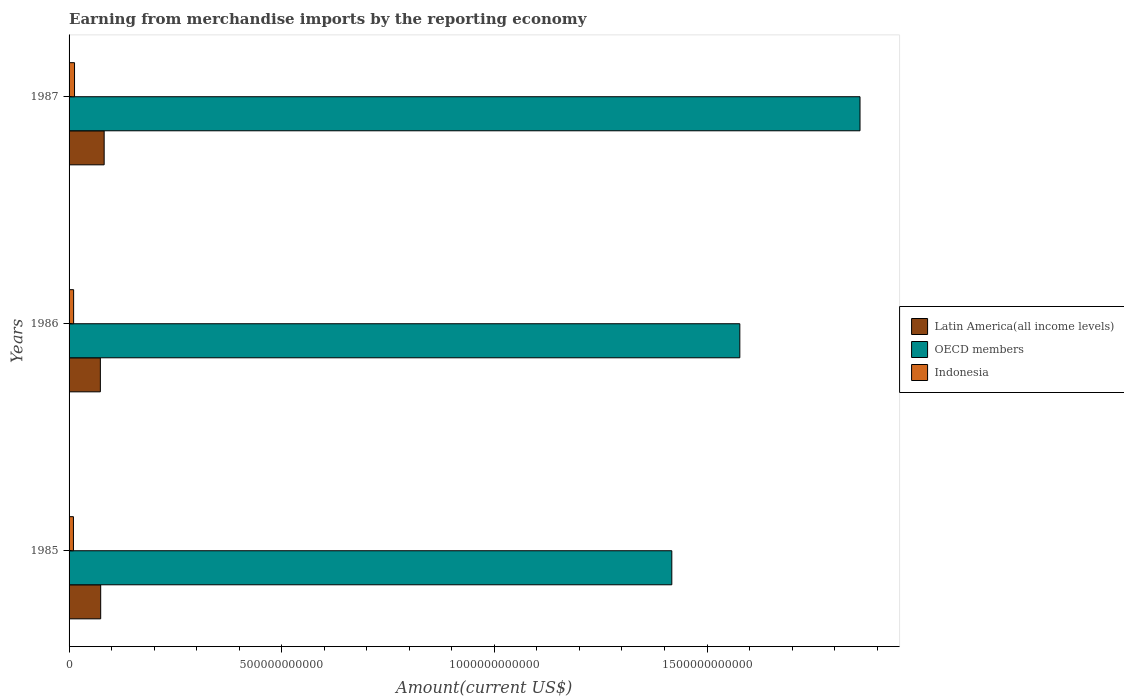How many different coloured bars are there?
Offer a very short reply. 3. Are the number of bars per tick equal to the number of legend labels?
Offer a very short reply. Yes. How many bars are there on the 1st tick from the top?
Give a very brief answer. 3. What is the label of the 3rd group of bars from the top?
Your answer should be compact. 1985. In how many cases, is the number of bars for a given year not equal to the number of legend labels?
Your answer should be very brief. 0. What is the amount earned from merchandise imports in OECD members in 1986?
Provide a short and direct response. 1.58e+12. Across all years, what is the maximum amount earned from merchandise imports in Latin America(all income levels)?
Ensure brevity in your answer.  8.25e+1. Across all years, what is the minimum amount earned from merchandise imports in Latin America(all income levels)?
Make the answer very short. 7.36e+1. In which year was the amount earned from merchandise imports in Indonesia maximum?
Make the answer very short. 1987. In which year was the amount earned from merchandise imports in Latin America(all income levels) minimum?
Provide a succinct answer. 1986. What is the total amount earned from merchandise imports in Indonesia in the graph?
Keep it short and to the point. 3.39e+1. What is the difference between the amount earned from merchandise imports in Indonesia in 1985 and that in 1986?
Your answer should be very brief. -4.50e+08. What is the difference between the amount earned from merchandise imports in Latin America(all income levels) in 1985 and the amount earned from merchandise imports in Indonesia in 1986?
Ensure brevity in your answer.  6.36e+1. What is the average amount earned from merchandise imports in Latin America(all income levels) per year?
Your answer should be very brief. 7.68e+1. In the year 1986, what is the difference between the amount earned from merchandise imports in OECD members and amount earned from merchandise imports in Latin America(all income levels)?
Your answer should be very brief. 1.50e+12. In how many years, is the amount earned from merchandise imports in OECD members greater than 1700000000000 US$?
Offer a terse response. 1. What is the ratio of the amount earned from merchandise imports in Indonesia in 1985 to that in 1986?
Provide a succinct answer. 0.96. What is the difference between the highest and the second highest amount earned from merchandise imports in Latin America(all income levels)?
Provide a short and direct response. 8.19e+09. What is the difference between the highest and the lowest amount earned from merchandise imports in Indonesia?
Provide a short and direct response. 2.58e+09. What does the 3rd bar from the top in 1987 represents?
Make the answer very short. Latin America(all income levels). What does the 1st bar from the bottom in 1986 represents?
Give a very brief answer. Latin America(all income levels). What is the difference between two consecutive major ticks on the X-axis?
Offer a very short reply. 5.00e+11. Does the graph contain any zero values?
Your answer should be very brief. No. Where does the legend appear in the graph?
Offer a very short reply. Center right. What is the title of the graph?
Make the answer very short. Earning from merchandise imports by the reporting economy. What is the label or title of the X-axis?
Your answer should be very brief. Amount(current US$). What is the label or title of the Y-axis?
Your response must be concise. Years. What is the Amount(current US$) of Latin America(all income levels) in 1985?
Offer a very short reply. 7.43e+1. What is the Amount(current US$) of OECD members in 1985?
Your response must be concise. 1.42e+12. What is the Amount(current US$) of Indonesia in 1985?
Your answer should be compact. 1.03e+1. What is the Amount(current US$) in Latin America(all income levels) in 1986?
Offer a very short reply. 7.36e+1. What is the Amount(current US$) of OECD members in 1986?
Make the answer very short. 1.58e+12. What is the Amount(current US$) of Indonesia in 1986?
Provide a short and direct response. 1.07e+1. What is the Amount(current US$) in Latin America(all income levels) in 1987?
Your answer should be compact. 8.25e+1. What is the Amount(current US$) of OECD members in 1987?
Offer a very short reply. 1.86e+12. What is the Amount(current US$) of Indonesia in 1987?
Your answer should be very brief. 1.29e+1. Across all years, what is the maximum Amount(current US$) in Latin America(all income levels)?
Provide a short and direct response. 8.25e+1. Across all years, what is the maximum Amount(current US$) in OECD members?
Ensure brevity in your answer.  1.86e+12. Across all years, what is the maximum Amount(current US$) of Indonesia?
Give a very brief answer. 1.29e+1. Across all years, what is the minimum Amount(current US$) of Latin America(all income levels)?
Provide a succinct answer. 7.36e+1. Across all years, what is the minimum Amount(current US$) of OECD members?
Keep it short and to the point. 1.42e+12. Across all years, what is the minimum Amount(current US$) in Indonesia?
Provide a succinct answer. 1.03e+1. What is the total Amount(current US$) in Latin America(all income levels) in the graph?
Provide a short and direct response. 2.30e+11. What is the total Amount(current US$) of OECD members in the graph?
Offer a very short reply. 4.85e+12. What is the total Amount(current US$) of Indonesia in the graph?
Make the answer very short. 3.39e+1. What is the difference between the Amount(current US$) in Latin America(all income levels) in 1985 and that in 1986?
Your answer should be very brief. 7.55e+08. What is the difference between the Amount(current US$) of OECD members in 1985 and that in 1986?
Provide a short and direct response. -1.60e+11. What is the difference between the Amount(current US$) in Indonesia in 1985 and that in 1986?
Your response must be concise. -4.50e+08. What is the difference between the Amount(current US$) of Latin America(all income levels) in 1985 and that in 1987?
Keep it short and to the point. -8.19e+09. What is the difference between the Amount(current US$) of OECD members in 1985 and that in 1987?
Keep it short and to the point. -4.43e+11. What is the difference between the Amount(current US$) in Indonesia in 1985 and that in 1987?
Offer a terse response. -2.58e+09. What is the difference between the Amount(current US$) in Latin America(all income levels) in 1986 and that in 1987?
Ensure brevity in your answer.  -8.95e+09. What is the difference between the Amount(current US$) in OECD members in 1986 and that in 1987?
Offer a very short reply. -2.83e+11. What is the difference between the Amount(current US$) of Indonesia in 1986 and that in 1987?
Your answer should be very brief. -2.13e+09. What is the difference between the Amount(current US$) of Latin America(all income levels) in 1985 and the Amount(current US$) of OECD members in 1986?
Keep it short and to the point. -1.50e+12. What is the difference between the Amount(current US$) in Latin America(all income levels) in 1985 and the Amount(current US$) in Indonesia in 1986?
Keep it short and to the point. 6.36e+1. What is the difference between the Amount(current US$) in OECD members in 1985 and the Amount(current US$) in Indonesia in 1986?
Your response must be concise. 1.41e+12. What is the difference between the Amount(current US$) of Latin America(all income levels) in 1985 and the Amount(current US$) of OECD members in 1987?
Offer a terse response. -1.79e+12. What is the difference between the Amount(current US$) of Latin America(all income levels) in 1985 and the Amount(current US$) of Indonesia in 1987?
Provide a succinct answer. 6.15e+1. What is the difference between the Amount(current US$) in OECD members in 1985 and the Amount(current US$) in Indonesia in 1987?
Your answer should be very brief. 1.40e+12. What is the difference between the Amount(current US$) in Latin America(all income levels) in 1986 and the Amount(current US$) in OECD members in 1987?
Give a very brief answer. -1.79e+12. What is the difference between the Amount(current US$) in Latin America(all income levels) in 1986 and the Amount(current US$) in Indonesia in 1987?
Offer a terse response. 6.07e+1. What is the difference between the Amount(current US$) of OECD members in 1986 and the Amount(current US$) of Indonesia in 1987?
Make the answer very short. 1.56e+12. What is the average Amount(current US$) in Latin America(all income levels) per year?
Ensure brevity in your answer.  7.68e+1. What is the average Amount(current US$) of OECD members per year?
Offer a very short reply. 1.62e+12. What is the average Amount(current US$) in Indonesia per year?
Your answer should be very brief. 1.13e+1. In the year 1985, what is the difference between the Amount(current US$) of Latin America(all income levels) and Amount(current US$) of OECD members?
Provide a succinct answer. -1.34e+12. In the year 1985, what is the difference between the Amount(current US$) of Latin America(all income levels) and Amount(current US$) of Indonesia?
Offer a very short reply. 6.40e+1. In the year 1985, what is the difference between the Amount(current US$) in OECD members and Amount(current US$) in Indonesia?
Your answer should be very brief. 1.41e+12. In the year 1986, what is the difference between the Amount(current US$) in Latin America(all income levels) and Amount(current US$) in OECD members?
Your response must be concise. -1.50e+12. In the year 1986, what is the difference between the Amount(current US$) in Latin America(all income levels) and Amount(current US$) in Indonesia?
Provide a succinct answer. 6.28e+1. In the year 1986, what is the difference between the Amount(current US$) in OECD members and Amount(current US$) in Indonesia?
Your answer should be very brief. 1.57e+12. In the year 1987, what is the difference between the Amount(current US$) in Latin America(all income levels) and Amount(current US$) in OECD members?
Provide a short and direct response. -1.78e+12. In the year 1987, what is the difference between the Amount(current US$) in Latin America(all income levels) and Amount(current US$) in Indonesia?
Offer a terse response. 6.97e+1. In the year 1987, what is the difference between the Amount(current US$) of OECD members and Amount(current US$) of Indonesia?
Keep it short and to the point. 1.85e+12. What is the ratio of the Amount(current US$) in Latin America(all income levels) in 1985 to that in 1986?
Make the answer very short. 1.01. What is the ratio of the Amount(current US$) in OECD members in 1985 to that in 1986?
Offer a terse response. 0.9. What is the ratio of the Amount(current US$) in Indonesia in 1985 to that in 1986?
Offer a terse response. 0.96. What is the ratio of the Amount(current US$) of Latin America(all income levels) in 1985 to that in 1987?
Offer a very short reply. 0.9. What is the ratio of the Amount(current US$) of OECD members in 1985 to that in 1987?
Your response must be concise. 0.76. What is the ratio of the Amount(current US$) in Indonesia in 1985 to that in 1987?
Your answer should be very brief. 0.8. What is the ratio of the Amount(current US$) in Latin America(all income levels) in 1986 to that in 1987?
Ensure brevity in your answer.  0.89. What is the ratio of the Amount(current US$) of OECD members in 1986 to that in 1987?
Offer a terse response. 0.85. What is the ratio of the Amount(current US$) of Indonesia in 1986 to that in 1987?
Offer a terse response. 0.83. What is the difference between the highest and the second highest Amount(current US$) in Latin America(all income levels)?
Provide a succinct answer. 8.19e+09. What is the difference between the highest and the second highest Amount(current US$) in OECD members?
Your answer should be compact. 2.83e+11. What is the difference between the highest and the second highest Amount(current US$) of Indonesia?
Keep it short and to the point. 2.13e+09. What is the difference between the highest and the lowest Amount(current US$) of Latin America(all income levels)?
Offer a terse response. 8.95e+09. What is the difference between the highest and the lowest Amount(current US$) of OECD members?
Ensure brevity in your answer.  4.43e+11. What is the difference between the highest and the lowest Amount(current US$) of Indonesia?
Make the answer very short. 2.58e+09. 